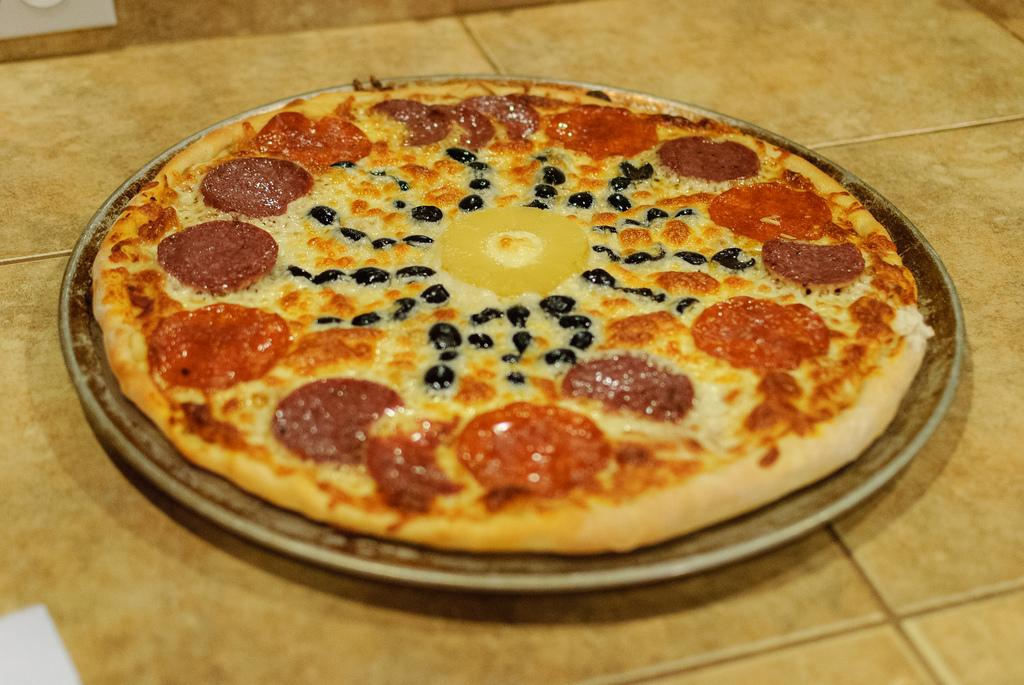What type of food is visible in the image? There is a pizza in the image. How is the pizza presented in the image? The pizza is in a plate. Where is the plate with the pizza located? The plate with the pizza is placed on a table. What type of mass can be seen in the image? There is no mass present in the image; it features a pizza in a plate on a table. What type of eggnog is being served with the pizza in the image? There is no eggnog present in the image; it features a pizza in a plate on a table. 